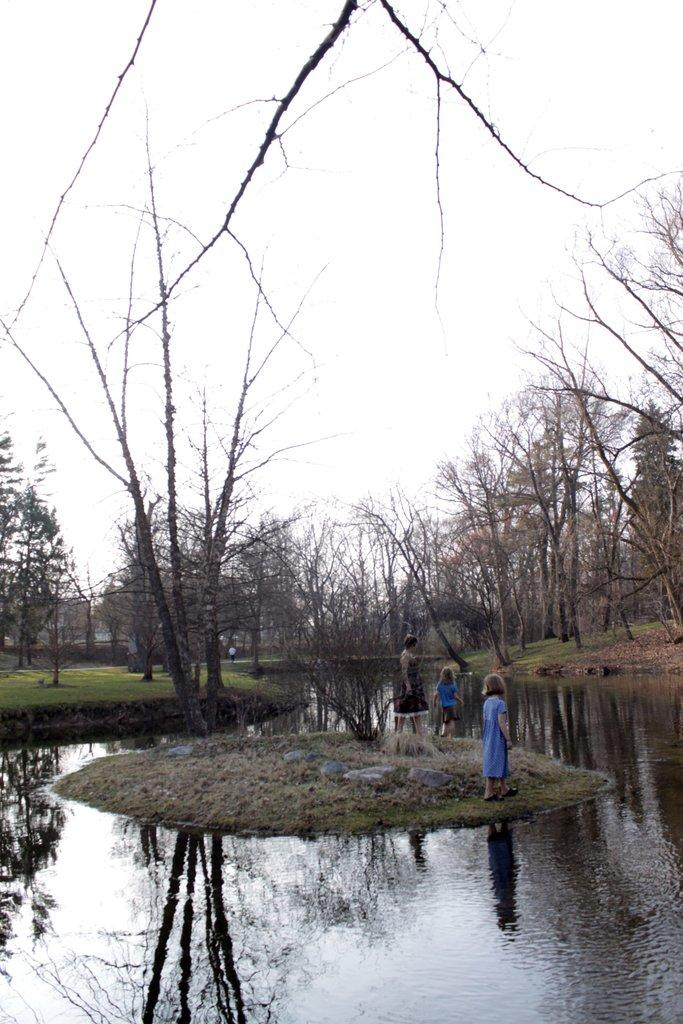How many people are in the image? There are three persons standing on the ground in the image. What type of vegetation can be seen in the image? There are trees in the image. What natural element is visible in the image? There is water visible in the image. What type of ground surface is present in the image? There is grass in the image. What part of the natural environment is visible in the image? The sky is visible in the image. What letters are being used by the persons in the image? There are no letters visible in the image, and the persons are not shown using any letters. What type of badge is being worn by the trees in the image? There are no badges present in the image, and the trees are not wearing any badges. 